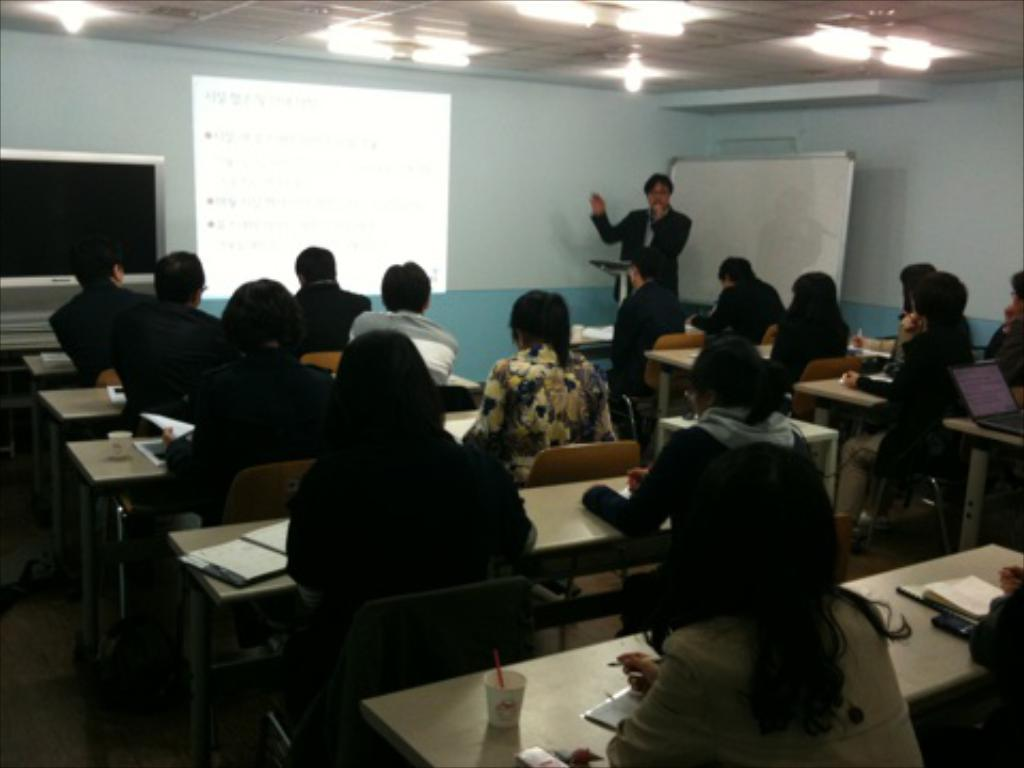What are the people in the image doing? There is a group of people sitting in chairs. Can you describe the background of the image? There is a man, a screen, a television, a board, and a light in the background. What might the people be watching or observing? They might be watching the television or observing the screen and board in the background. What type of chain can be seen hanging from the ceiling in the image? There is no chain visible in the image. Can you tell me how many ducks are present in the image? There are no ducks present in the image. 